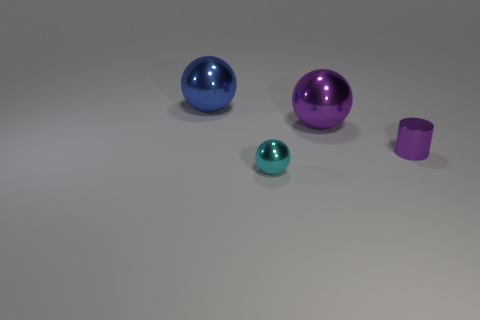Is there anything else that has the same shape as the tiny purple shiny object?
Your answer should be compact. No. The metallic cylinder is what size?
Your response must be concise. Small. There is a shiny object that is both in front of the big blue shiny ball and behind the tiny cylinder; what is its shape?
Provide a short and direct response. Sphere. There is another big thing that is the same shape as the big blue thing; what color is it?
Provide a short and direct response. Purple. What number of things are tiny shiny objects that are to the right of the tiny sphere or purple spheres to the right of the blue metallic sphere?
Provide a succinct answer. 2. What is the shape of the tiny purple object?
Keep it short and to the point. Cylinder. What number of cyan objects have the same material as the large purple sphere?
Give a very brief answer. 1. The tiny metallic sphere has what color?
Give a very brief answer. Cyan. What is the color of the shiny cylinder that is the same size as the cyan ball?
Provide a succinct answer. Purple. Are there any metallic things of the same color as the small metallic cylinder?
Your answer should be compact. Yes. 